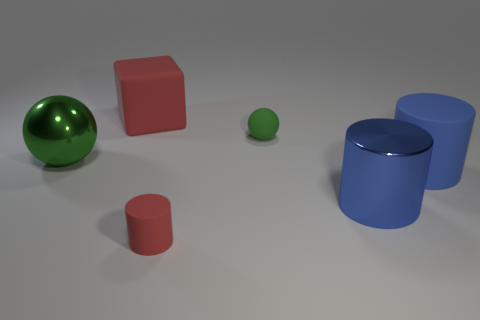What is the material of the small green object?
Your answer should be very brief. Rubber. What is the size of the red object that is in front of the metal sphere?
Your response must be concise. Small. There is a red rubber object behind the tiny ball; what number of green balls are left of it?
Give a very brief answer. 1. Do the metallic thing that is behind the large blue matte cylinder and the green thing right of the tiny rubber cylinder have the same shape?
Offer a very short reply. Yes. What number of things are in front of the big rubber cylinder and right of the small green matte thing?
Provide a succinct answer. 1. Is there a matte cylinder that has the same color as the cube?
Your answer should be very brief. Yes. What shape is the other blue thing that is the same size as the blue rubber object?
Offer a terse response. Cylinder. There is a big matte block; are there any large blue cylinders to the right of it?
Provide a succinct answer. Yes. Do the green sphere that is on the right side of the small red rubber object and the big cylinder on the right side of the large blue shiny object have the same material?
Your answer should be very brief. Yes. What number of cylinders are the same size as the matte ball?
Offer a terse response. 1. 